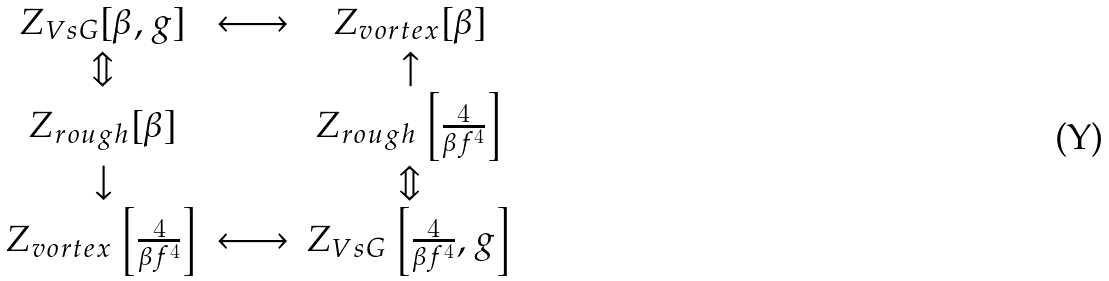<formula> <loc_0><loc_0><loc_500><loc_500>\begin{array} { c c c } Z _ { V s G } [ \beta , g ] & \longleftrightarrow & Z _ { v o r t e x } [ \beta ] \\ \Updownarrow & & \uparrow \\ Z _ { r o u g h } [ \beta ] & & Z _ { r o u g h } \left [ \frac { 4 } { \beta f ^ { 4 } } \right ] \\ \downarrow & & \Updownarrow \\ Z _ { v o r t e x } \left [ \frac { 4 } { \beta f ^ { 4 } } \right ] & \longleftrightarrow & Z _ { V s G } \left [ \frac { 4 } { \beta f ^ { 4 } } , g \right ] \end{array}</formula> 